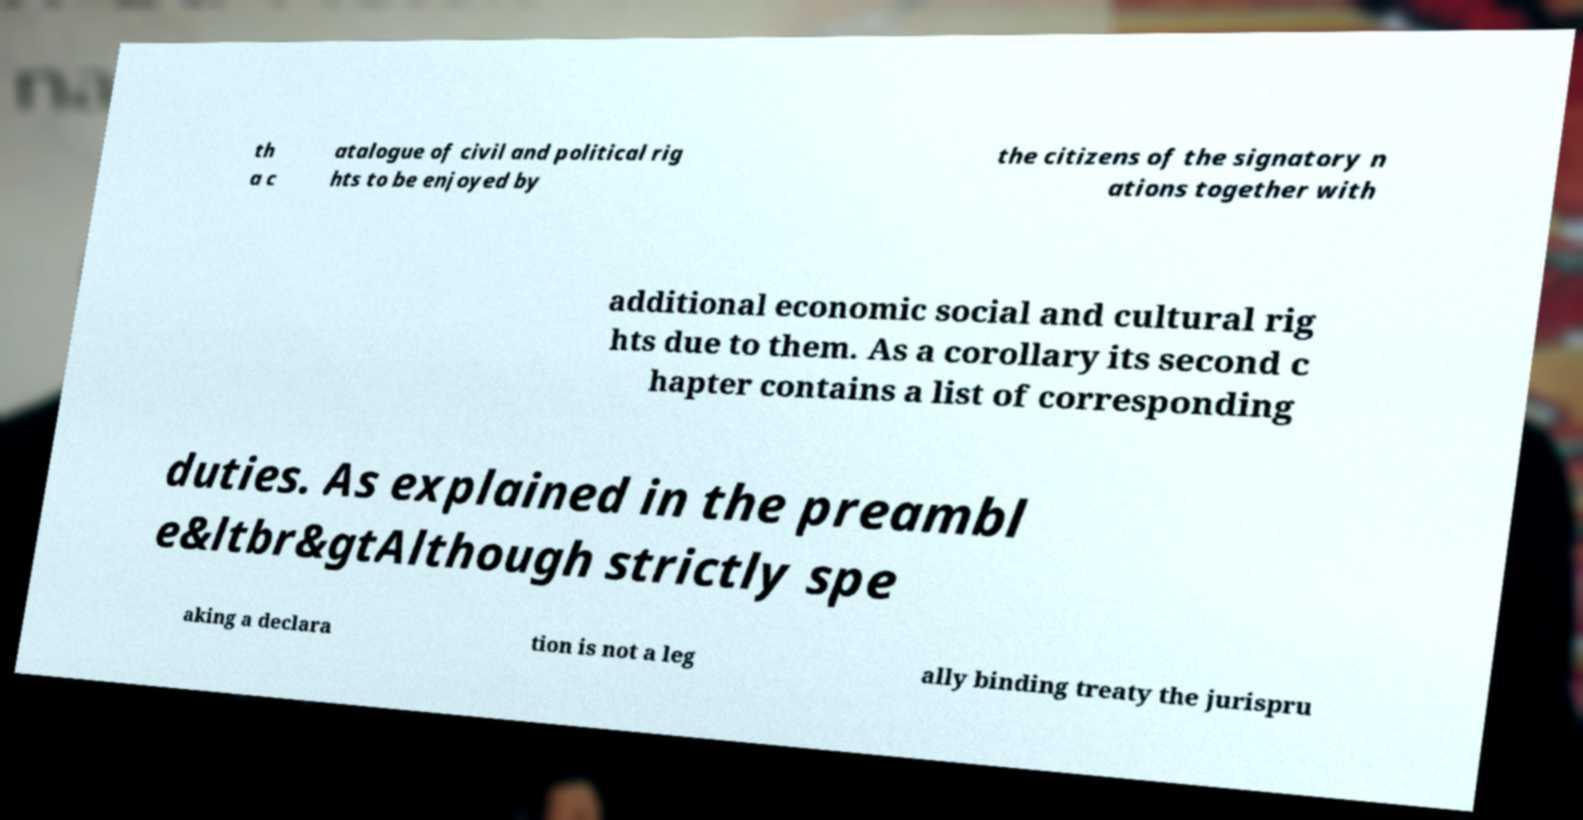I need the written content from this picture converted into text. Can you do that? th a c atalogue of civil and political rig hts to be enjoyed by the citizens of the signatory n ations together with additional economic social and cultural rig hts due to them. As a corollary its second c hapter contains a list of corresponding duties. As explained in the preambl e&ltbr&gtAlthough strictly spe aking a declara tion is not a leg ally binding treaty the jurispru 